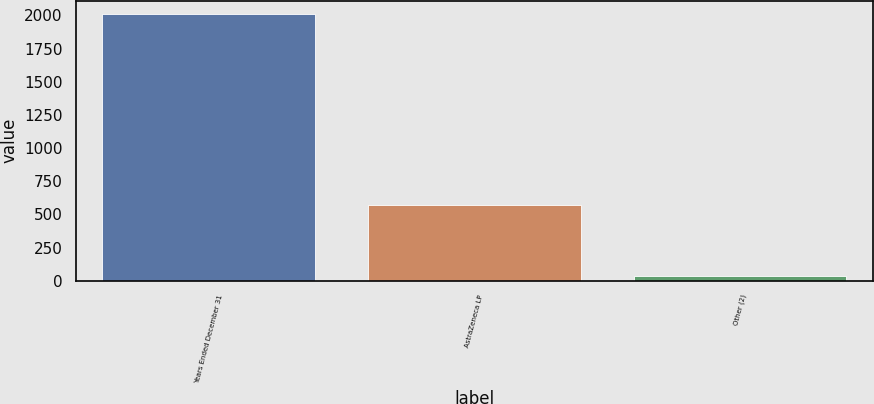<chart> <loc_0><loc_0><loc_500><loc_500><bar_chart><fcel>Years Ended December 31<fcel>AstraZeneca LP<fcel>Other (2)<nl><fcel>2011<fcel>574<fcel>36<nl></chart> 